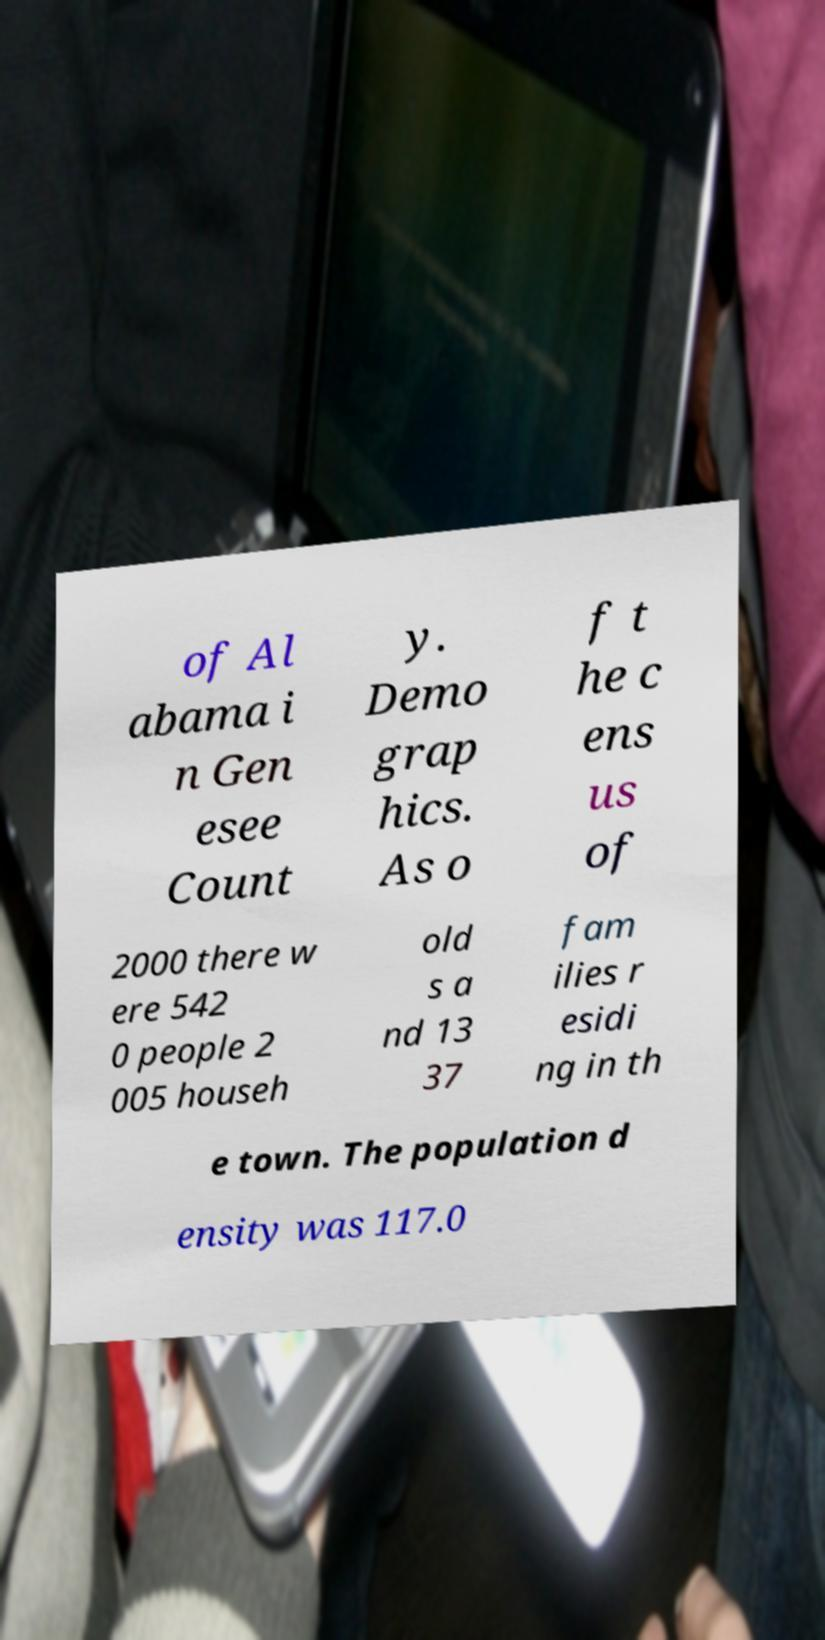For documentation purposes, I need the text within this image transcribed. Could you provide that? of Al abama i n Gen esee Count y. Demo grap hics. As o f t he c ens us of 2000 there w ere 542 0 people 2 005 househ old s a nd 13 37 fam ilies r esidi ng in th e town. The population d ensity was 117.0 